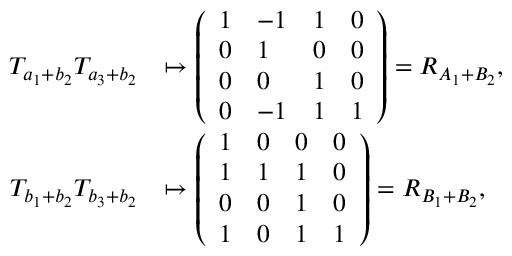Convert formula to latex. <formula><loc_0><loc_0><loc_500><loc_500>\begin{array} { r l } { T _ { a _ { 1 } + b _ { 2 } } T _ { a _ { 3 } + b _ { 2 } } } & { \mapsto \left ( \begin{array} { l l l l } { 1 } & { - 1 } & { 1 } & { 0 } \\ { 0 } & { 1 } & { 0 } & { 0 } \\ { 0 } & { 0 } & { 1 } & { 0 } \\ { 0 } & { - 1 } & { 1 } & { 1 } \end{array} \right ) = R _ { A _ { 1 } + B _ { 2 } } , } \\ { T _ { b _ { 1 } + b _ { 2 } } T _ { b _ { 3 } + b _ { 2 } } } & { \mapsto \left ( \begin{array} { l l l l } { 1 } & { 0 } & { 0 } & { 0 } \\ { 1 } & { 1 } & { 1 } & { 0 } \\ { 0 } & { 0 } & { 1 } & { 0 } \\ { 1 } & { 0 } & { 1 } & { 1 } \end{array} \right ) = R _ { B _ { 1 } + B _ { 2 } } , } \end{array}</formula> 